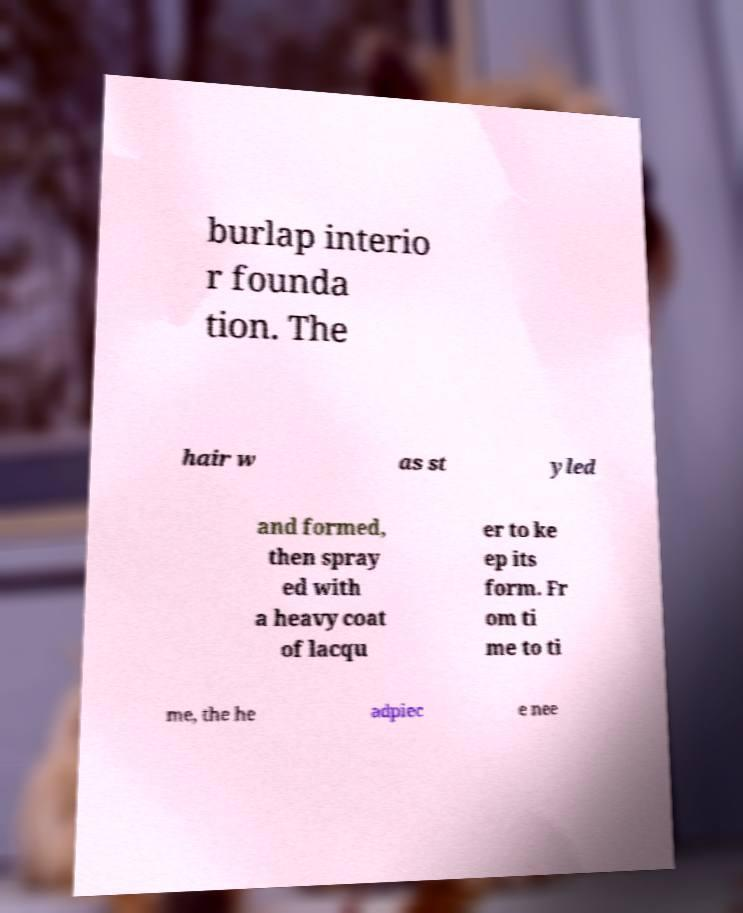Could you extract and type out the text from this image? burlap interio r founda tion. The hair w as st yled and formed, then spray ed with a heavy coat of lacqu er to ke ep its form. Fr om ti me to ti me, the he adpiec e nee 